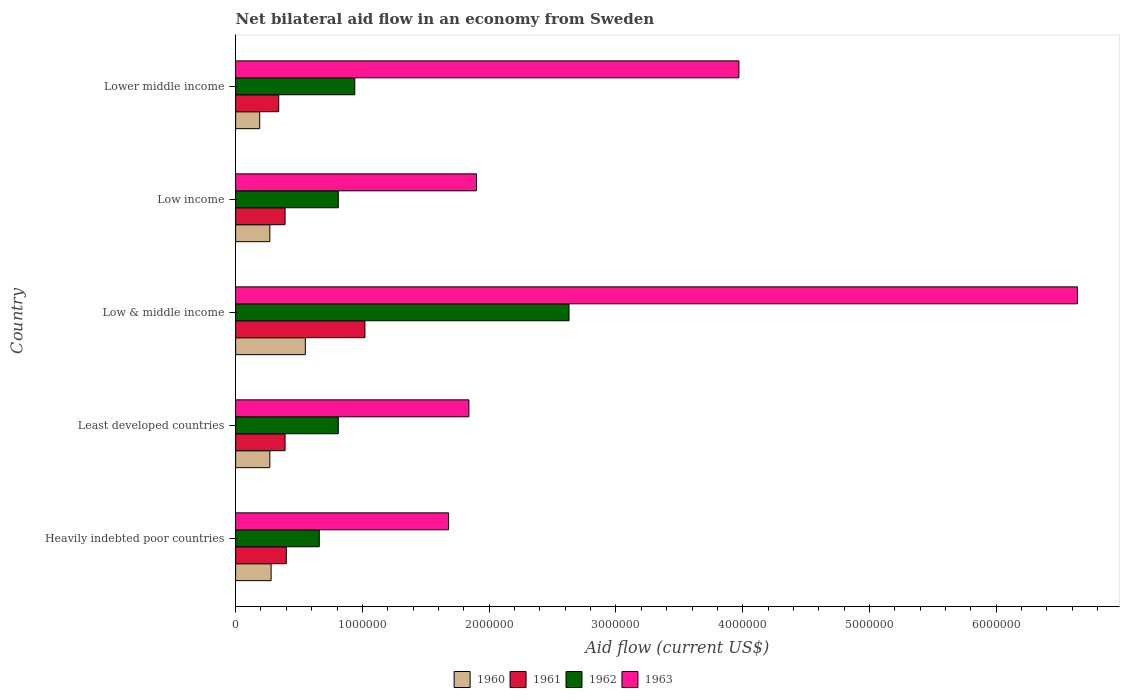How many different coloured bars are there?
Provide a short and direct response. 4. Are the number of bars per tick equal to the number of legend labels?
Offer a very short reply. Yes. How many bars are there on the 3rd tick from the top?
Provide a succinct answer. 4. What is the net bilateral aid flow in 1962 in Least developed countries?
Provide a short and direct response. 8.10e+05. Across all countries, what is the maximum net bilateral aid flow in 1963?
Give a very brief answer. 6.64e+06. Across all countries, what is the minimum net bilateral aid flow in 1963?
Offer a very short reply. 1.68e+06. In which country was the net bilateral aid flow in 1962 maximum?
Provide a short and direct response. Low & middle income. In which country was the net bilateral aid flow in 1963 minimum?
Provide a succinct answer. Heavily indebted poor countries. What is the total net bilateral aid flow in 1961 in the graph?
Keep it short and to the point. 2.54e+06. What is the difference between the net bilateral aid flow in 1960 in Low income and that in Lower middle income?
Ensure brevity in your answer.  8.00e+04. What is the difference between the net bilateral aid flow in 1961 in Lower middle income and the net bilateral aid flow in 1962 in Low income?
Ensure brevity in your answer.  -4.70e+05. What is the average net bilateral aid flow in 1961 per country?
Give a very brief answer. 5.08e+05. What is the ratio of the net bilateral aid flow in 1963 in Heavily indebted poor countries to that in Low income?
Your answer should be compact. 0.88. Is the net bilateral aid flow in 1960 in Least developed countries less than that in Low & middle income?
Provide a short and direct response. Yes. Is the difference between the net bilateral aid flow in 1961 in Least developed countries and Lower middle income greater than the difference between the net bilateral aid flow in 1962 in Least developed countries and Lower middle income?
Make the answer very short. Yes. What is the difference between the highest and the lowest net bilateral aid flow in 1961?
Provide a short and direct response. 6.80e+05. In how many countries, is the net bilateral aid flow in 1962 greater than the average net bilateral aid flow in 1962 taken over all countries?
Your answer should be compact. 1. Is the sum of the net bilateral aid flow in 1963 in Heavily indebted poor countries and Lower middle income greater than the maximum net bilateral aid flow in 1961 across all countries?
Your response must be concise. Yes. Is it the case that in every country, the sum of the net bilateral aid flow in 1961 and net bilateral aid flow in 1960 is greater than the sum of net bilateral aid flow in 1963 and net bilateral aid flow in 1962?
Your answer should be very brief. No. Are all the bars in the graph horizontal?
Offer a terse response. Yes. What is the difference between two consecutive major ticks on the X-axis?
Offer a very short reply. 1.00e+06. Are the values on the major ticks of X-axis written in scientific E-notation?
Offer a terse response. No. Does the graph contain grids?
Your response must be concise. No. What is the title of the graph?
Offer a very short reply. Net bilateral aid flow in an economy from Sweden. Does "1967" appear as one of the legend labels in the graph?
Your answer should be very brief. No. What is the Aid flow (current US$) of 1960 in Heavily indebted poor countries?
Provide a short and direct response. 2.80e+05. What is the Aid flow (current US$) in 1961 in Heavily indebted poor countries?
Your answer should be compact. 4.00e+05. What is the Aid flow (current US$) in 1963 in Heavily indebted poor countries?
Keep it short and to the point. 1.68e+06. What is the Aid flow (current US$) of 1961 in Least developed countries?
Provide a succinct answer. 3.90e+05. What is the Aid flow (current US$) in 1962 in Least developed countries?
Provide a short and direct response. 8.10e+05. What is the Aid flow (current US$) of 1963 in Least developed countries?
Ensure brevity in your answer.  1.84e+06. What is the Aid flow (current US$) of 1960 in Low & middle income?
Keep it short and to the point. 5.50e+05. What is the Aid flow (current US$) of 1961 in Low & middle income?
Your answer should be compact. 1.02e+06. What is the Aid flow (current US$) of 1962 in Low & middle income?
Provide a succinct answer. 2.63e+06. What is the Aid flow (current US$) in 1963 in Low & middle income?
Your response must be concise. 6.64e+06. What is the Aid flow (current US$) in 1960 in Low income?
Provide a short and direct response. 2.70e+05. What is the Aid flow (current US$) in 1961 in Low income?
Ensure brevity in your answer.  3.90e+05. What is the Aid flow (current US$) of 1962 in Low income?
Offer a very short reply. 8.10e+05. What is the Aid flow (current US$) of 1963 in Low income?
Your answer should be very brief. 1.90e+06. What is the Aid flow (current US$) of 1961 in Lower middle income?
Give a very brief answer. 3.40e+05. What is the Aid flow (current US$) of 1962 in Lower middle income?
Keep it short and to the point. 9.40e+05. What is the Aid flow (current US$) of 1963 in Lower middle income?
Offer a very short reply. 3.97e+06. Across all countries, what is the maximum Aid flow (current US$) in 1961?
Offer a very short reply. 1.02e+06. Across all countries, what is the maximum Aid flow (current US$) of 1962?
Give a very brief answer. 2.63e+06. Across all countries, what is the maximum Aid flow (current US$) of 1963?
Give a very brief answer. 6.64e+06. Across all countries, what is the minimum Aid flow (current US$) of 1963?
Give a very brief answer. 1.68e+06. What is the total Aid flow (current US$) in 1960 in the graph?
Ensure brevity in your answer.  1.56e+06. What is the total Aid flow (current US$) of 1961 in the graph?
Your answer should be compact. 2.54e+06. What is the total Aid flow (current US$) in 1962 in the graph?
Keep it short and to the point. 5.85e+06. What is the total Aid flow (current US$) in 1963 in the graph?
Give a very brief answer. 1.60e+07. What is the difference between the Aid flow (current US$) of 1960 in Heavily indebted poor countries and that in Least developed countries?
Give a very brief answer. 10000. What is the difference between the Aid flow (current US$) in 1961 in Heavily indebted poor countries and that in Least developed countries?
Ensure brevity in your answer.  10000. What is the difference between the Aid flow (current US$) in 1961 in Heavily indebted poor countries and that in Low & middle income?
Your answer should be compact. -6.20e+05. What is the difference between the Aid flow (current US$) of 1962 in Heavily indebted poor countries and that in Low & middle income?
Give a very brief answer. -1.97e+06. What is the difference between the Aid flow (current US$) of 1963 in Heavily indebted poor countries and that in Low & middle income?
Offer a very short reply. -4.96e+06. What is the difference between the Aid flow (current US$) in 1960 in Heavily indebted poor countries and that in Low income?
Offer a terse response. 10000. What is the difference between the Aid flow (current US$) of 1962 in Heavily indebted poor countries and that in Low income?
Your response must be concise. -1.50e+05. What is the difference between the Aid flow (current US$) in 1963 in Heavily indebted poor countries and that in Low income?
Provide a short and direct response. -2.20e+05. What is the difference between the Aid flow (current US$) of 1960 in Heavily indebted poor countries and that in Lower middle income?
Provide a short and direct response. 9.00e+04. What is the difference between the Aid flow (current US$) in 1962 in Heavily indebted poor countries and that in Lower middle income?
Provide a short and direct response. -2.80e+05. What is the difference between the Aid flow (current US$) of 1963 in Heavily indebted poor countries and that in Lower middle income?
Give a very brief answer. -2.29e+06. What is the difference between the Aid flow (current US$) in 1960 in Least developed countries and that in Low & middle income?
Make the answer very short. -2.80e+05. What is the difference between the Aid flow (current US$) in 1961 in Least developed countries and that in Low & middle income?
Offer a very short reply. -6.30e+05. What is the difference between the Aid flow (current US$) of 1962 in Least developed countries and that in Low & middle income?
Your response must be concise. -1.82e+06. What is the difference between the Aid flow (current US$) in 1963 in Least developed countries and that in Low & middle income?
Your answer should be very brief. -4.80e+06. What is the difference between the Aid flow (current US$) of 1963 in Least developed countries and that in Low income?
Make the answer very short. -6.00e+04. What is the difference between the Aid flow (current US$) of 1963 in Least developed countries and that in Lower middle income?
Keep it short and to the point. -2.13e+06. What is the difference between the Aid flow (current US$) in 1961 in Low & middle income and that in Low income?
Keep it short and to the point. 6.30e+05. What is the difference between the Aid flow (current US$) of 1962 in Low & middle income and that in Low income?
Your answer should be very brief. 1.82e+06. What is the difference between the Aid flow (current US$) of 1963 in Low & middle income and that in Low income?
Your answer should be compact. 4.74e+06. What is the difference between the Aid flow (current US$) in 1961 in Low & middle income and that in Lower middle income?
Keep it short and to the point. 6.80e+05. What is the difference between the Aid flow (current US$) in 1962 in Low & middle income and that in Lower middle income?
Make the answer very short. 1.69e+06. What is the difference between the Aid flow (current US$) of 1963 in Low & middle income and that in Lower middle income?
Keep it short and to the point. 2.67e+06. What is the difference between the Aid flow (current US$) in 1961 in Low income and that in Lower middle income?
Provide a short and direct response. 5.00e+04. What is the difference between the Aid flow (current US$) of 1962 in Low income and that in Lower middle income?
Your response must be concise. -1.30e+05. What is the difference between the Aid flow (current US$) in 1963 in Low income and that in Lower middle income?
Give a very brief answer. -2.07e+06. What is the difference between the Aid flow (current US$) in 1960 in Heavily indebted poor countries and the Aid flow (current US$) in 1962 in Least developed countries?
Your response must be concise. -5.30e+05. What is the difference between the Aid flow (current US$) in 1960 in Heavily indebted poor countries and the Aid flow (current US$) in 1963 in Least developed countries?
Give a very brief answer. -1.56e+06. What is the difference between the Aid flow (current US$) of 1961 in Heavily indebted poor countries and the Aid flow (current US$) of 1962 in Least developed countries?
Your answer should be very brief. -4.10e+05. What is the difference between the Aid flow (current US$) of 1961 in Heavily indebted poor countries and the Aid flow (current US$) of 1963 in Least developed countries?
Your response must be concise. -1.44e+06. What is the difference between the Aid flow (current US$) in 1962 in Heavily indebted poor countries and the Aid flow (current US$) in 1963 in Least developed countries?
Offer a very short reply. -1.18e+06. What is the difference between the Aid flow (current US$) in 1960 in Heavily indebted poor countries and the Aid flow (current US$) in 1961 in Low & middle income?
Your answer should be very brief. -7.40e+05. What is the difference between the Aid flow (current US$) in 1960 in Heavily indebted poor countries and the Aid flow (current US$) in 1962 in Low & middle income?
Make the answer very short. -2.35e+06. What is the difference between the Aid flow (current US$) in 1960 in Heavily indebted poor countries and the Aid flow (current US$) in 1963 in Low & middle income?
Your response must be concise. -6.36e+06. What is the difference between the Aid flow (current US$) in 1961 in Heavily indebted poor countries and the Aid flow (current US$) in 1962 in Low & middle income?
Your answer should be compact. -2.23e+06. What is the difference between the Aid flow (current US$) in 1961 in Heavily indebted poor countries and the Aid flow (current US$) in 1963 in Low & middle income?
Keep it short and to the point. -6.24e+06. What is the difference between the Aid flow (current US$) of 1962 in Heavily indebted poor countries and the Aid flow (current US$) of 1963 in Low & middle income?
Your response must be concise. -5.98e+06. What is the difference between the Aid flow (current US$) of 1960 in Heavily indebted poor countries and the Aid flow (current US$) of 1961 in Low income?
Keep it short and to the point. -1.10e+05. What is the difference between the Aid flow (current US$) of 1960 in Heavily indebted poor countries and the Aid flow (current US$) of 1962 in Low income?
Make the answer very short. -5.30e+05. What is the difference between the Aid flow (current US$) of 1960 in Heavily indebted poor countries and the Aid flow (current US$) of 1963 in Low income?
Make the answer very short. -1.62e+06. What is the difference between the Aid flow (current US$) in 1961 in Heavily indebted poor countries and the Aid flow (current US$) in 1962 in Low income?
Offer a terse response. -4.10e+05. What is the difference between the Aid flow (current US$) in 1961 in Heavily indebted poor countries and the Aid flow (current US$) in 1963 in Low income?
Provide a short and direct response. -1.50e+06. What is the difference between the Aid flow (current US$) of 1962 in Heavily indebted poor countries and the Aid flow (current US$) of 1963 in Low income?
Offer a terse response. -1.24e+06. What is the difference between the Aid flow (current US$) of 1960 in Heavily indebted poor countries and the Aid flow (current US$) of 1961 in Lower middle income?
Offer a very short reply. -6.00e+04. What is the difference between the Aid flow (current US$) of 1960 in Heavily indebted poor countries and the Aid flow (current US$) of 1962 in Lower middle income?
Give a very brief answer. -6.60e+05. What is the difference between the Aid flow (current US$) of 1960 in Heavily indebted poor countries and the Aid flow (current US$) of 1963 in Lower middle income?
Offer a very short reply. -3.69e+06. What is the difference between the Aid flow (current US$) in 1961 in Heavily indebted poor countries and the Aid flow (current US$) in 1962 in Lower middle income?
Keep it short and to the point. -5.40e+05. What is the difference between the Aid flow (current US$) in 1961 in Heavily indebted poor countries and the Aid flow (current US$) in 1963 in Lower middle income?
Ensure brevity in your answer.  -3.57e+06. What is the difference between the Aid flow (current US$) of 1962 in Heavily indebted poor countries and the Aid flow (current US$) of 1963 in Lower middle income?
Your answer should be compact. -3.31e+06. What is the difference between the Aid flow (current US$) of 1960 in Least developed countries and the Aid flow (current US$) of 1961 in Low & middle income?
Offer a very short reply. -7.50e+05. What is the difference between the Aid flow (current US$) in 1960 in Least developed countries and the Aid flow (current US$) in 1962 in Low & middle income?
Your answer should be compact. -2.36e+06. What is the difference between the Aid flow (current US$) in 1960 in Least developed countries and the Aid flow (current US$) in 1963 in Low & middle income?
Your response must be concise. -6.37e+06. What is the difference between the Aid flow (current US$) of 1961 in Least developed countries and the Aid flow (current US$) of 1962 in Low & middle income?
Give a very brief answer. -2.24e+06. What is the difference between the Aid flow (current US$) of 1961 in Least developed countries and the Aid flow (current US$) of 1963 in Low & middle income?
Keep it short and to the point. -6.25e+06. What is the difference between the Aid flow (current US$) in 1962 in Least developed countries and the Aid flow (current US$) in 1963 in Low & middle income?
Keep it short and to the point. -5.83e+06. What is the difference between the Aid flow (current US$) in 1960 in Least developed countries and the Aid flow (current US$) in 1962 in Low income?
Offer a very short reply. -5.40e+05. What is the difference between the Aid flow (current US$) in 1960 in Least developed countries and the Aid flow (current US$) in 1963 in Low income?
Keep it short and to the point. -1.63e+06. What is the difference between the Aid flow (current US$) of 1961 in Least developed countries and the Aid flow (current US$) of 1962 in Low income?
Your response must be concise. -4.20e+05. What is the difference between the Aid flow (current US$) of 1961 in Least developed countries and the Aid flow (current US$) of 1963 in Low income?
Make the answer very short. -1.51e+06. What is the difference between the Aid flow (current US$) in 1962 in Least developed countries and the Aid flow (current US$) in 1963 in Low income?
Offer a terse response. -1.09e+06. What is the difference between the Aid flow (current US$) of 1960 in Least developed countries and the Aid flow (current US$) of 1962 in Lower middle income?
Give a very brief answer. -6.70e+05. What is the difference between the Aid flow (current US$) of 1960 in Least developed countries and the Aid flow (current US$) of 1963 in Lower middle income?
Provide a short and direct response. -3.70e+06. What is the difference between the Aid flow (current US$) in 1961 in Least developed countries and the Aid flow (current US$) in 1962 in Lower middle income?
Your response must be concise. -5.50e+05. What is the difference between the Aid flow (current US$) of 1961 in Least developed countries and the Aid flow (current US$) of 1963 in Lower middle income?
Provide a succinct answer. -3.58e+06. What is the difference between the Aid flow (current US$) of 1962 in Least developed countries and the Aid flow (current US$) of 1963 in Lower middle income?
Provide a succinct answer. -3.16e+06. What is the difference between the Aid flow (current US$) in 1960 in Low & middle income and the Aid flow (current US$) in 1961 in Low income?
Offer a very short reply. 1.60e+05. What is the difference between the Aid flow (current US$) of 1960 in Low & middle income and the Aid flow (current US$) of 1962 in Low income?
Give a very brief answer. -2.60e+05. What is the difference between the Aid flow (current US$) of 1960 in Low & middle income and the Aid flow (current US$) of 1963 in Low income?
Offer a very short reply. -1.35e+06. What is the difference between the Aid flow (current US$) in 1961 in Low & middle income and the Aid flow (current US$) in 1962 in Low income?
Provide a short and direct response. 2.10e+05. What is the difference between the Aid flow (current US$) of 1961 in Low & middle income and the Aid flow (current US$) of 1963 in Low income?
Give a very brief answer. -8.80e+05. What is the difference between the Aid flow (current US$) of 1962 in Low & middle income and the Aid flow (current US$) of 1963 in Low income?
Your response must be concise. 7.30e+05. What is the difference between the Aid flow (current US$) of 1960 in Low & middle income and the Aid flow (current US$) of 1961 in Lower middle income?
Your response must be concise. 2.10e+05. What is the difference between the Aid flow (current US$) of 1960 in Low & middle income and the Aid flow (current US$) of 1962 in Lower middle income?
Keep it short and to the point. -3.90e+05. What is the difference between the Aid flow (current US$) in 1960 in Low & middle income and the Aid flow (current US$) in 1963 in Lower middle income?
Keep it short and to the point. -3.42e+06. What is the difference between the Aid flow (current US$) of 1961 in Low & middle income and the Aid flow (current US$) of 1963 in Lower middle income?
Give a very brief answer. -2.95e+06. What is the difference between the Aid flow (current US$) in 1962 in Low & middle income and the Aid flow (current US$) in 1963 in Lower middle income?
Keep it short and to the point. -1.34e+06. What is the difference between the Aid flow (current US$) of 1960 in Low income and the Aid flow (current US$) of 1961 in Lower middle income?
Give a very brief answer. -7.00e+04. What is the difference between the Aid flow (current US$) in 1960 in Low income and the Aid flow (current US$) in 1962 in Lower middle income?
Your response must be concise. -6.70e+05. What is the difference between the Aid flow (current US$) of 1960 in Low income and the Aid flow (current US$) of 1963 in Lower middle income?
Make the answer very short. -3.70e+06. What is the difference between the Aid flow (current US$) in 1961 in Low income and the Aid flow (current US$) in 1962 in Lower middle income?
Make the answer very short. -5.50e+05. What is the difference between the Aid flow (current US$) of 1961 in Low income and the Aid flow (current US$) of 1963 in Lower middle income?
Offer a terse response. -3.58e+06. What is the difference between the Aid flow (current US$) of 1962 in Low income and the Aid flow (current US$) of 1963 in Lower middle income?
Keep it short and to the point. -3.16e+06. What is the average Aid flow (current US$) in 1960 per country?
Offer a terse response. 3.12e+05. What is the average Aid flow (current US$) in 1961 per country?
Offer a very short reply. 5.08e+05. What is the average Aid flow (current US$) of 1962 per country?
Your response must be concise. 1.17e+06. What is the average Aid flow (current US$) of 1963 per country?
Your answer should be very brief. 3.21e+06. What is the difference between the Aid flow (current US$) in 1960 and Aid flow (current US$) in 1962 in Heavily indebted poor countries?
Your answer should be very brief. -3.80e+05. What is the difference between the Aid flow (current US$) of 1960 and Aid flow (current US$) of 1963 in Heavily indebted poor countries?
Give a very brief answer. -1.40e+06. What is the difference between the Aid flow (current US$) in 1961 and Aid flow (current US$) in 1963 in Heavily indebted poor countries?
Provide a succinct answer. -1.28e+06. What is the difference between the Aid flow (current US$) in 1962 and Aid flow (current US$) in 1963 in Heavily indebted poor countries?
Keep it short and to the point. -1.02e+06. What is the difference between the Aid flow (current US$) of 1960 and Aid flow (current US$) of 1962 in Least developed countries?
Your answer should be compact. -5.40e+05. What is the difference between the Aid flow (current US$) in 1960 and Aid flow (current US$) in 1963 in Least developed countries?
Ensure brevity in your answer.  -1.57e+06. What is the difference between the Aid flow (current US$) in 1961 and Aid flow (current US$) in 1962 in Least developed countries?
Provide a succinct answer. -4.20e+05. What is the difference between the Aid flow (current US$) of 1961 and Aid flow (current US$) of 1963 in Least developed countries?
Offer a terse response. -1.45e+06. What is the difference between the Aid flow (current US$) in 1962 and Aid flow (current US$) in 1963 in Least developed countries?
Offer a very short reply. -1.03e+06. What is the difference between the Aid flow (current US$) in 1960 and Aid flow (current US$) in 1961 in Low & middle income?
Offer a very short reply. -4.70e+05. What is the difference between the Aid flow (current US$) of 1960 and Aid flow (current US$) of 1962 in Low & middle income?
Your answer should be very brief. -2.08e+06. What is the difference between the Aid flow (current US$) in 1960 and Aid flow (current US$) in 1963 in Low & middle income?
Provide a succinct answer. -6.09e+06. What is the difference between the Aid flow (current US$) of 1961 and Aid flow (current US$) of 1962 in Low & middle income?
Make the answer very short. -1.61e+06. What is the difference between the Aid flow (current US$) in 1961 and Aid flow (current US$) in 1963 in Low & middle income?
Provide a succinct answer. -5.62e+06. What is the difference between the Aid flow (current US$) in 1962 and Aid flow (current US$) in 1963 in Low & middle income?
Your answer should be compact. -4.01e+06. What is the difference between the Aid flow (current US$) of 1960 and Aid flow (current US$) of 1961 in Low income?
Give a very brief answer. -1.20e+05. What is the difference between the Aid flow (current US$) in 1960 and Aid flow (current US$) in 1962 in Low income?
Provide a short and direct response. -5.40e+05. What is the difference between the Aid flow (current US$) of 1960 and Aid flow (current US$) of 1963 in Low income?
Provide a short and direct response. -1.63e+06. What is the difference between the Aid flow (current US$) in 1961 and Aid flow (current US$) in 1962 in Low income?
Provide a succinct answer. -4.20e+05. What is the difference between the Aid flow (current US$) of 1961 and Aid flow (current US$) of 1963 in Low income?
Keep it short and to the point. -1.51e+06. What is the difference between the Aid flow (current US$) in 1962 and Aid flow (current US$) in 1963 in Low income?
Offer a terse response. -1.09e+06. What is the difference between the Aid flow (current US$) of 1960 and Aid flow (current US$) of 1961 in Lower middle income?
Your answer should be very brief. -1.50e+05. What is the difference between the Aid flow (current US$) in 1960 and Aid flow (current US$) in 1962 in Lower middle income?
Your answer should be compact. -7.50e+05. What is the difference between the Aid flow (current US$) of 1960 and Aid flow (current US$) of 1963 in Lower middle income?
Offer a very short reply. -3.78e+06. What is the difference between the Aid flow (current US$) of 1961 and Aid flow (current US$) of 1962 in Lower middle income?
Offer a very short reply. -6.00e+05. What is the difference between the Aid flow (current US$) of 1961 and Aid flow (current US$) of 1963 in Lower middle income?
Your answer should be very brief. -3.63e+06. What is the difference between the Aid flow (current US$) in 1962 and Aid flow (current US$) in 1963 in Lower middle income?
Give a very brief answer. -3.03e+06. What is the ratio of the Aid flow (current US$) of 1960 in Heavily indebted poor countries to that in Least developed countries?
Your response must be concise. 1.04. What is the ratio of the Aid flow (current US$) in 1961 in Heavily indebted poor countries to that in Least developed countries?
Give a very brief answer. 1.03. What is the ratio of the Aid flow (current US$) in 1962 in Heavily indebted poor countries to that in Least developed countries?
Give a very brief answer. 0.81. What is the ratio of the Aid flow (current US$) in 1960 in Heavily indebted poor countries to that in Low & middle income?
Provide a succinct answer. 0.51. What is the ratio of the Aid flow (current US$) in 1961 in Heavily indebted poor countries to that in Low & middle income?
Provide a succinct answer. 0.39. What is the ratio of the Aid flow (current US$) of 1962 in Heavily indebted poor countries to that in Low & middle income?
Offer a very short reply. 0.25. What is the ratio of the Aid flow (current US$) in 1963 in Heavily indebted poor countries to that in Low & middle income?
Your answer should be compact. 0.25. What is the ratio of the Aid flow (current US$) in 1960 in Heavily indebted poor countries to that in Low income?
Offer a very short reply. 1.04. What is the ratio of the Aid flow (current US$) in 1961 in Heavily indebted poor countries to that in Low income?
Provide a succinct answer. 1.03. What is the ratio of the Aid flow (current US$) of 1962 in Heavily indebted poor countries to that in Low income?
Your answer should be compact. 0.81. What is the ratio of the Aid flow (current US$) of 1963 in Heavily indebted poor countries to that in Low income?
Provide a short and direct response. 0.88. What is the ratio of the Aid flow (current US$) of 1960 in Heavily indebted poor countries to that in Lower middle income?
Give a very brief answer. 1.47. What is the ratio of the Aid flow (current US$) in 1961 in Heavily indebted poor countries to that in Lower middle income?
Your answer should be very brief. 1.18. What is the ratio of the Aid flow (current US$) of 1962 in Heavily indebted poor countries to that in Lower middle income?
Your answer should be compact. 0.7. What is the ratio of the Aid flow (current US$) in 1963 in Heavily indebted poor countries to that in Lower middle income?
Your answer should be very brief. 0.42. What is the ratio of the Aid flow (current US$) in 1960 in Least developed countries to that in Low & middle income?
Provide a short and direct response. 0.49. What is the ratio of the Aid flow (current US$) of 1961 in Least developed countries to that in Low & middle income?
Provide a succinct answer. 0.38. What is the ratio of the Aid flow (current US$) of 1962 in Least developed countries to that in Low & middle income?
Give a very brief answer. 0.31. What is the ratio of the Aid flow (current US$) of 1963 in Least developed countries to that in Low & middle income?
Offer a terse response. 0.28. What is the ratio of the Aid flow (current US$) in 1960 in Least developed countries to that in Low income?
Keep it short and to the point. 1. What is the ratio of the Aid flow (current US$) in 1962 in Least developed countries to that in Low income?
Offer a very short reply. 1. What is the ratio of the Aid flow (current US$) of 1963 in Least developed countries to that in Low income?
Your response must be concise. 0.97. What is the ratio of the Aid flow (current US$) in 1960 in Least developed countries to that in Lower middle income?
Give a very brief answer. 1.42. What is the ratio of the Aid flow (current US$) of 1961 in Least developed countries to that in Lower middle income?
Make the answer very short. 1.15. What is the ratio of the Aid flow (current US$) in 1962 in Least developed countries to that in Lower middle income?
Make the answer very short. 0.86. What is the ratio of the Aid flow (current US$) of 1963 in Least developed countries to that in Lower middle income?
Keep it short and to the point. 0.46. What is the ratio of the Aid flow (current US$) in 1960 in Low & middle income to that in Low income?
Offer a terse response. 2.04. What is the ratio of the Aid flow (current US$) in 1961 in Low & middle income to that in Low income?
Your answer should be compact. 2.62. What is the ratio of the Aid flow (current US$) in 1962 in Low & middle income to that in Low income?
Give a very brief answer. 3.25. What is the ratio of the Aid flow (current US$) in 1963 in Low & middle income to that in Low income?
Your response must be concise. 3.49. What is the ratio of the Aid flow (current US$) in 1960 in Low & middle income to that in Lower middle income?
Ensure brevity in your answer.  2.89. What is the ratio of the Aid flow (current US$) in 1962 in Low & middle income to that in Lower middle income?
Give a very brief answer. 2.8. What is the ratio of the Aid flow (current US$) of 1963 in Low & middle income to that in Lower middle income?
Your response must be concise. 1.67. What is the ratio of the Aid flow (current US$) in 1960 in Low income to that in Lower middle income?
Give a very brief answer. 1.42. What is the ratio of the Aid flow (current US$) of 1961 in Low income to that in Lower middle income?
Your answer should be compact. 1.15. What is the ratio of the Aid flow (current US$) in 1962 in Low income to that in Lower middle income?
Your answer should be compact. 0.86. What is the ratio of the Aid flow (current US$) in 1963 in Low income to that in Lower middle income?
Provide a succinct answer. 0.48. What is the difference between the highest and the second highest Aid flow (current US$) of 1961?
Your answer should be very brief. 6.20e+05. What is the difference between the highest and the second highest Aid flow (current US$) of 1962?
Make the answer very short. 1.69e+06. What is the difference between the highest and the second highest Aid flow (current US$) of 1963?
Offer a terse response. 2.67e+06. What is the difference between the highest and the lowest Aid flow (current US$) in 1960?
Ensure brevity in your answer.  3.60e+05. What is the difference between the highest and the lowest Aid flow (current US$) of 1961?
Your answer should be very brief. 6.80e+05. What is the difference between the highest and the lowest Aid flow (current US$) in 1962?
Your answer should be compact. 1.97e+06. What is the difference between the highest and the lowest Aid flow (current US$) in 1963?
Keep it short and to the point. 4.96e+06. 